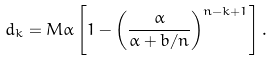<formula> <loc_0><loc_0><loc_500><loc_500>d _ { k } = M \alpha \left [ 1 - \left ( \frac { \alpha } { \alpha + b / n } \right ) ^ { n - k + 1 } \right ] .</formula> 